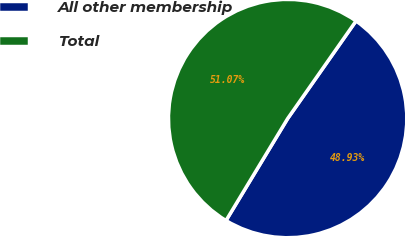Convert chart. <chart><loc_0><loc_0><loc_500><loc_500><pie_chart><fcel>All other membership<fcel>Total<nl><fcel>48.93%<fcel>51.07%<nl></chart> 